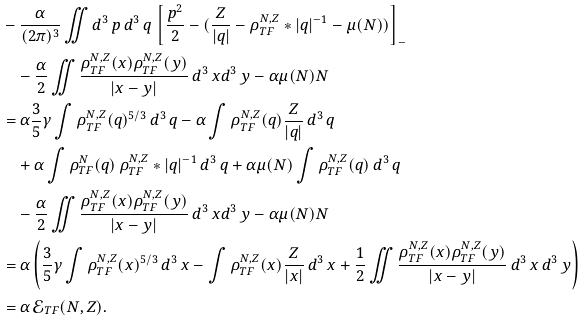<formula> <loc_0><loc_0><loc_500><loc_500>& - \frac { \alpha } { ( 2 \pi ) ^ { 3 } } \iint d ^ { 3 } \, p \, d ^ { 3 } \, q \, \left [ \frac { p ^ { 2 } } { 2 } - ( \frac { Z } { | q | } - \rho _ { T F } ^ { N , Z } * | q | ^ { - 1 } - \mu ( N ) ) \right ] _ { - } \\ & \quad - \frac { \alpha } { 2 } \iint \frac { \rho _ { T F } ^ { N , Z } ( x ) \rho _ { T F } ^ { N , Z } ( y ) } { | x - y | } \, d ^ { 3 } \, x d ^ { 3 } \, y - \alpha \mu ( N ) N \\ & = \alpha \frac { 3 } { 5 } \gamma \int \rho _ { T F } ^ { N , Z } ( q ) ^ { 5 / 3 } \, d ^ { 3 } \, q - \alpha \int \rho _ { T F } ^ { N , Z } ( q ) \frac { Z } { | q | } \, d ^ { 3 } \, q \\ & \quad + \alpha \int \rho _ { T F } ^ { N } ( q ) \, \rho _ { T F } ^ { N , Z } * | q | ^ { - 1 } \, d ^ { 3 } \, q + \alpha \mu ( N ) \int \rho _ { T F } ^ { N , Z } ( q ) \, d ^ { 3 } \, q \\ & \quad - \frac { \alpha } { 2 } \iint \frac { \rho _ { T F } ^ { N , Z } ( x ) \rho _ { T F } ^ { N , Z } ( y ) } { | x - y | } \, d ^ { 3 } \, x d ^ { 3 } \, y - \alpha \mu ( N ) N \\ & = \alpha \left ( \frac { 3 } { 5 } \gamma \int \rho _ { T F } ^ { N , Z } ( x ) ^ { 5 / 3 } \, d ^ { 3 } \, x - \int \rho _ { T F } ^ { N , Z } ( x ) \frac { Z } { | x | } \, d ^ { 3 } \, x + \frac { 1 } { 2 } \iint \frac { \rho _ { T F } ^ { N , Z } ( x ) \rho _ { T F } ^ { N , Z } ( y ) } { | x - y | } \, d ^ { 3 } \, x \, d ^ { 3 } \, y \right ) \\ & = \alpha \, \mathcal { E } _ { T F } ( N , Z ) .</formula> 